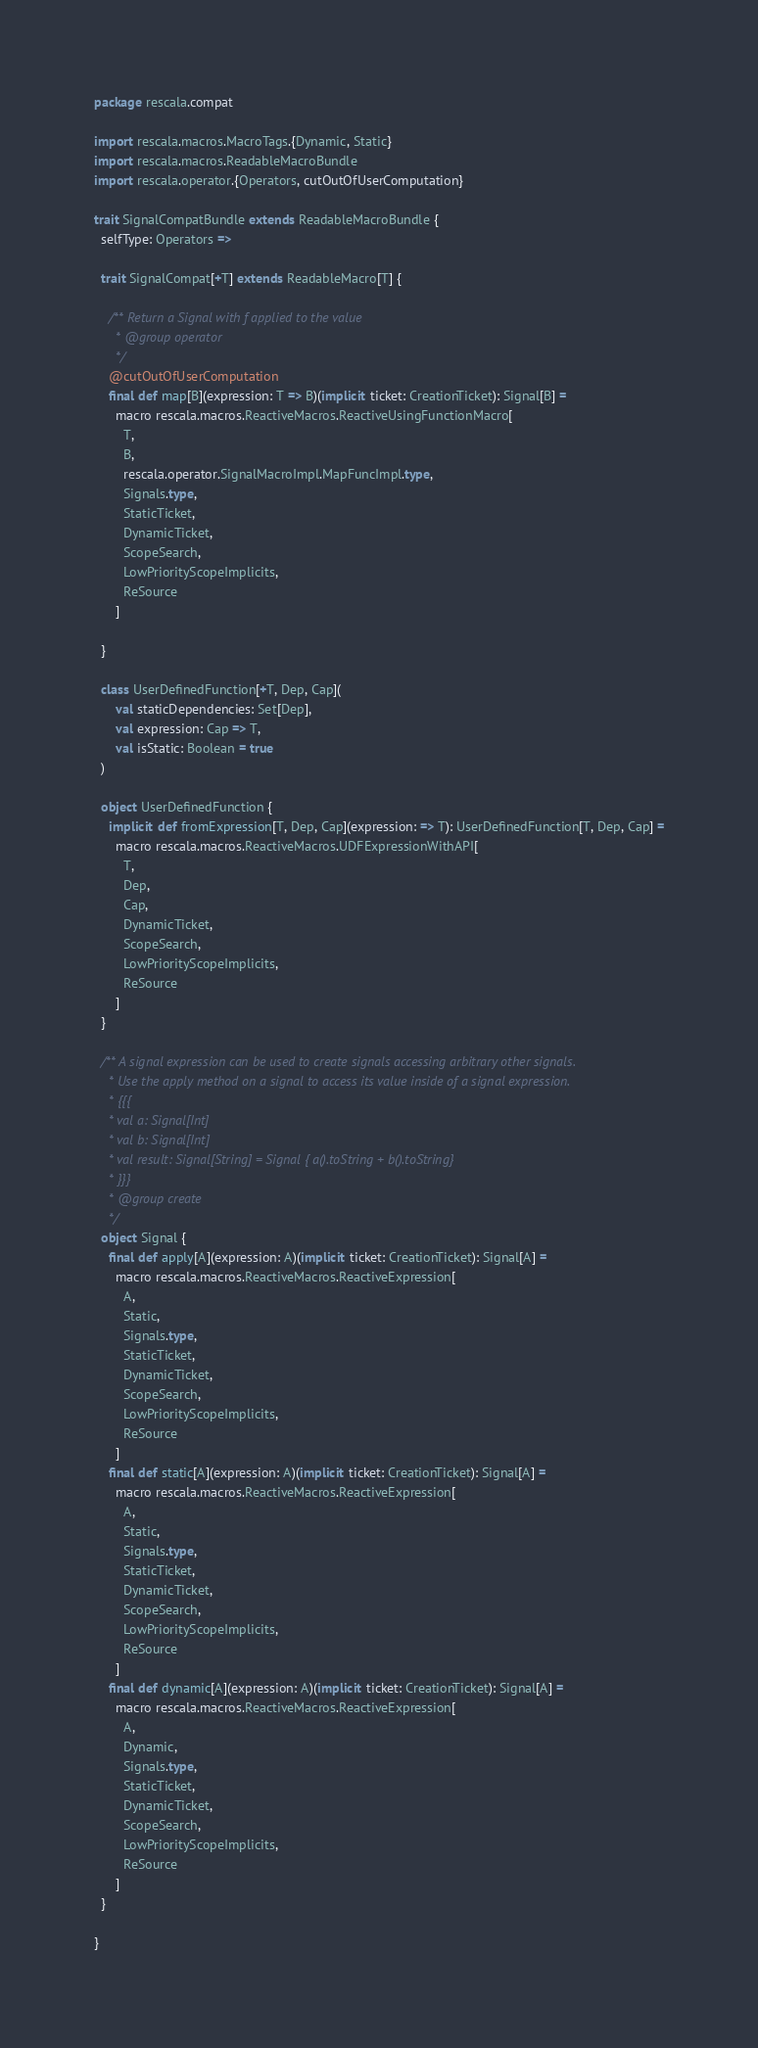Convert code to text. <code><loc_0><loc_0><loc_500><loc_500><_Scala_>package rescala.compat

import rescala.macros.MacroTags.{Dynamic, Static}
import rescala.macros.ReadableMacroBundle
import rescala.operator.{Operators, cutOutOfUserComputation}

trait SignalCompatBundle extends ReadableMacroBundle {
  selfType: Operators =>

  trait SignalCompat[+T] extends ReadableMacro[T] {

    /** Return a Signal with f applied to the value
      * @group operator
      */
    @cutOutOfUserComputation
    final def map[B](expression: T => B)(implicit ticket: CreationTicket): Signal[B] =
      macro rescala.macros.ReactiveMacros.ReactiveUsingFunctionMacro[
        T,
        B,
        rescala.operator.SignalMacroImpl.MapFuncImpl.type,
        Signals.type,
        StaticTicket,
        DynamicTicket,
        ScopeSearch,
        LowPriorityScopeImplicits,
        ReSource
      ]

  }

  class UserDefinedFunction[+T, Dep, Cap](
      val staticDependencies: Set[Dep],
      val expression: Cap => T,
      val isStatic: Boolean = true
  )

  object UserDefinedFunction {
    implicit def fromExpression[T, Dep, Cap](expression: => T): UserDefinedFunction[T, Dep, Cap] =
      macro rescala.macros.ReactiveMacros.UDFExpressionWithAPI[
        T,
        Dep,
        Cap,
        DynamicTicket,
        ScopeSearch,
        LowPriorityScopeImplicits,
        ReSource
      ]
  }

  /** A signal expression can be used to create signals accessing arbitrary other signals.
    * Use the apply method on a signal to access its value inside of a signal expression.
    * {{{
    * val a: Signal[Int]
    * val b: Signal[Int]
    * val result: Signal[String] = Signal { a().toString + b().toString}
    * }}}
    * @group create
    */
  object Signal {
    final def apply[A](expression: A)(implicit ticket: CreationTicket): Signal[A] =
      macro rescala.macros.ReactiveMacros.ReactiveExpression[
        A,
        Static,
        Signals.type,
        StaticTicket,
        DynamicTicket,
        ScopeSearch,
        LowPriorityScopeImplicits,
        ReSource
      ]
    final def static[A](expression: A)(implicit ticket: CreationTicket): Signal[A] =
      macro rescala.macros.ReactiveMacros.ReactiveExpression[
        A,
        Static,
        Signals.type,
        StaticTicket,
        DynamicTicket,
        ScopeSearch,
        LowPriorityScopeImplicits,
        ReSource
      ]
    final def dynamic[A](expression: A)(implicit ticket: CreationTicket): Signal[A] =
      macro rescala.macros.ReactiveMacros.ReactiveExpression[
        A,
        Dynamic,
        Signals.type,
        StaticTicket,
        DynamicTicket,
        ScopeSearch,
        LowPriorityScopeImplicits,
        ReSource
      ]
  }

}
</code> 